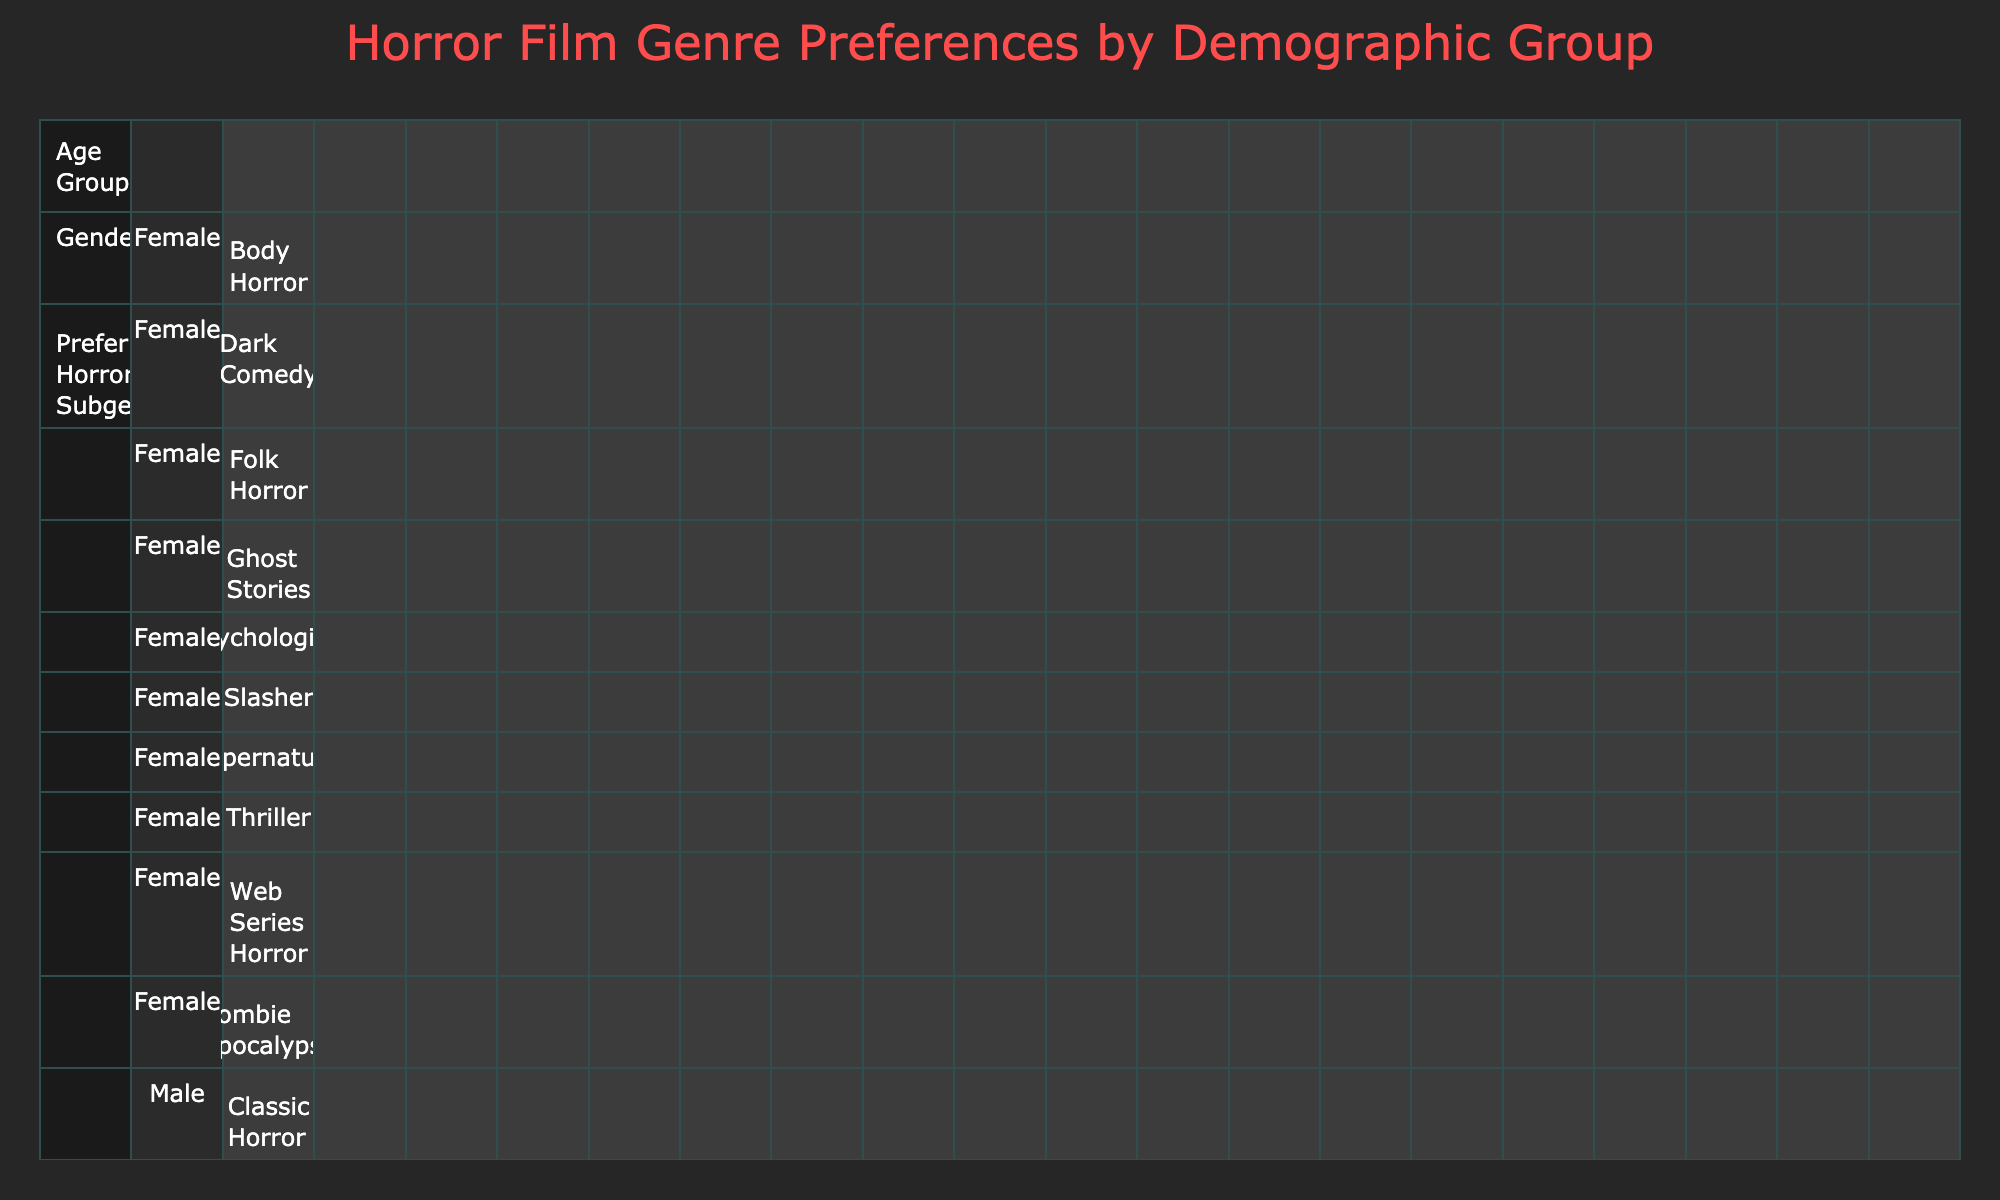What is the most preferred horror subgenre among 35-44 year old males? The table shows that the preferred horror subgenres for the age group 35-44 male are Cult Horror, Vampire Horror, and Zombie Apocalypse. The one with the highest different counts needs to be chosen. There are three preferences, but a clear “most preferred” subgenre cannot be determined from count.
Answer: Cult Horror How many females in the age group 45-54 prefer Dark Comedy? Looking at the table, there is one entry under the age group 45-54 for females, which indicates Dark Comedy as their preferred horror subgenre. Therefore, it’s directly taken as the answer.
Answer: 1 Is there a male in the 55+ age group who prefers Slasher? The table indicates that males in the 55+ group have three preferences: Psychological, Fantasy Horror, and then Web Series Horror. There is no mention of Slasher among those preferences, thus the answer is evident.
Answer: No Which subgenre has the highest overall number of preferences for 18-24 year old females? The table lists Supernatural and Psychological as preferences for females in the 18-24 age group, each appearing once. The count for either of these would be the same. Since neither has higher counts overall, it’s tied.
Answer: Tied (Supernatural and Psychological) What is the difference in the number of male and female preferences for Survival Horror in the age group 25-34? The table shows Survival Horror is listed under male preferences only and does not have any count for female preferences. Hence, the difference is simply the count of males.
Answer: 1 